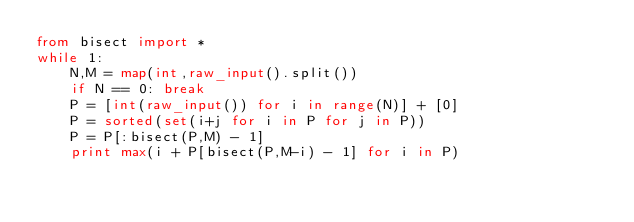Convert code to text. <code><loc_0><loc_0><loc_500><loc_500><_Python_>from bisect import *
while 1:
    N,M = map(int,raw_input().split())
    if N == 0: break
    P = [int(raw_input()) for i in range(N)] + [0]
    P = sorted(set(i+j for i in P for j in P))
    P = P[:bisect(P,M) - 1]
    print max(i + P[bisect(P,M-i) - 1] for i in P)</code> 